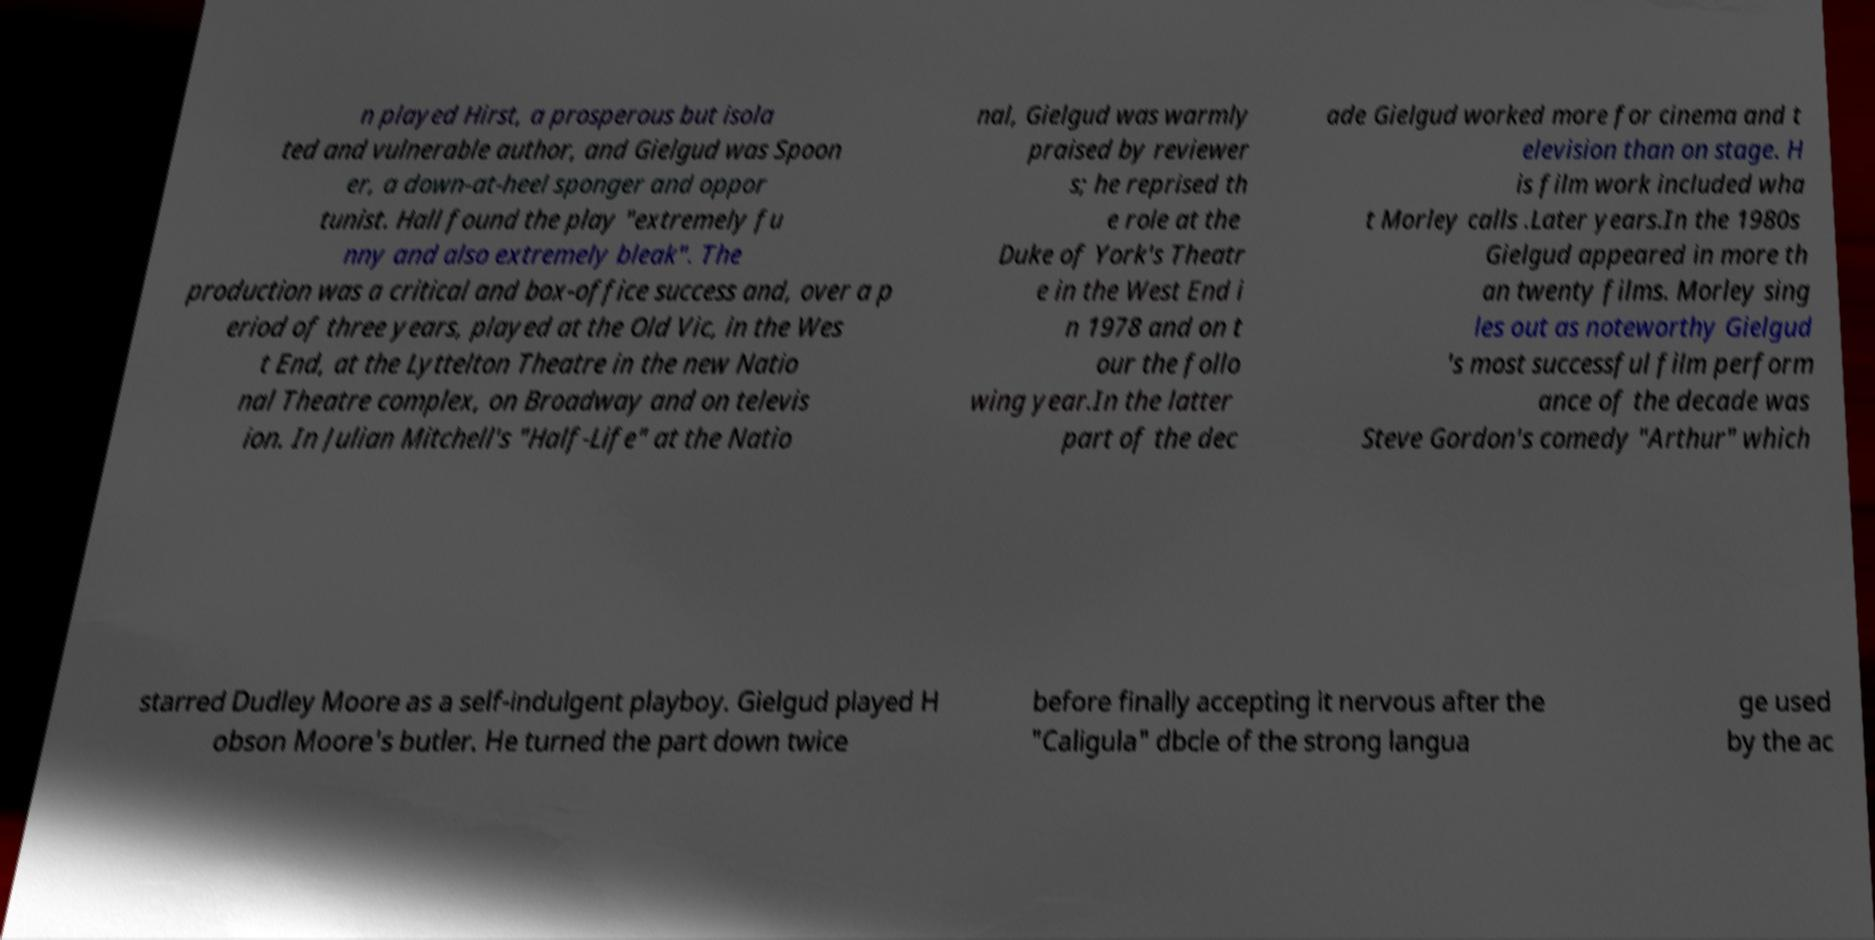Please read and relay the text visible in this image. What does it say? n played Hirst, a prosperous but isola ted and vulnerable author, and Gielgud was Spoon er, a down-at-heel sponger and oppor tunist. Hall found the play "extremely fu nny and also extremely bleak". The production was a critical and box-office success and, over a p eriod of three years, played at the Old Vic, in the Wes t End, at the Lyttelton Theatre in the new Natio nal Theatre complex, on Broadway and on televis ion. In Julian Mitchell's "Half-Life" at the Natio nal, Gielgud was warmly praised by reviewer s; he reprised th e role at the Duke of York's Theatr e in the West End i n 1978 and on t our the follo wing year.In the latter part of the dec ade Gielgud worked more for cinema and t elevision than on stage. H is film work included wha t Morley calls .Later years.In the 1980s Gielgud appeared in more th an twenty films. Morley sing les out as noteworthy Gielgud 's most successful film perform ance of the decade was Steve Gordon's comedy "Arthur" which starred Dudley Moore as a self-indulgent playboy. Gielgud played H obson Moore's butler. He turned the part down twice before finally accepting it nervous after the "Caligula" dbcle of the strong langua ge used by the ac 